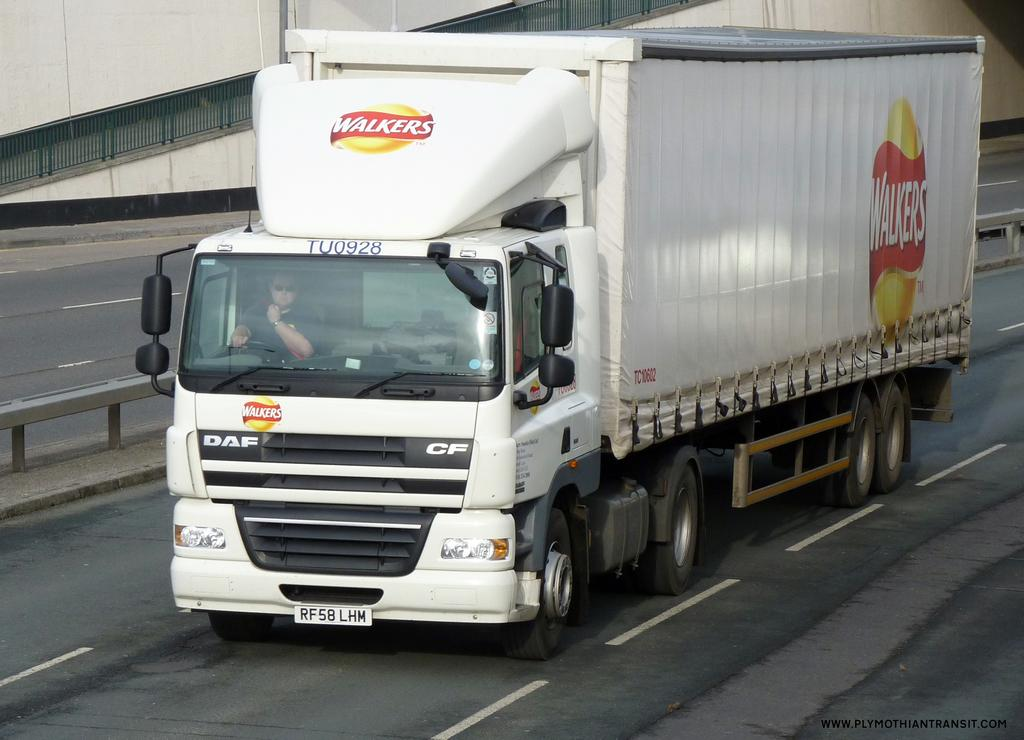Where was the image taken? The image was taken on the road. What is the main subject in the center of the image? There is a truck in the center of the image. What can be seen on the sides of the road in the image? There are railings in the image. What color is the wall visible in the image? The wall in the image is painted white. What type of butter is being used to stitch the railings in the image? There is no butter or stitching activity present in the image. 